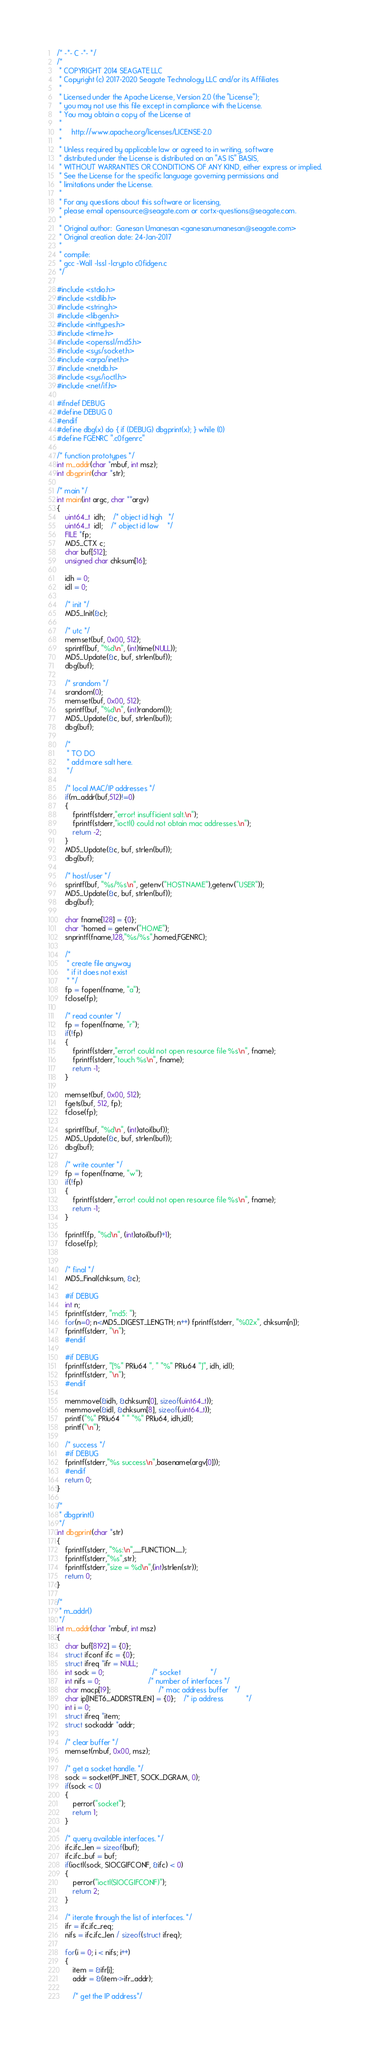Convert code to text. <code><loc_0><loc_0><loc_500><loc_500><_C_>/* -*- C -*- */
/*
 * COPYRIGHT 2014 SEAGATE LLC
 * Copyright (c) 2017-2020 Seagate Technology LLC and/or its Affiliates
 *
 * Licensed under the Apache License, Version 2.0 (the "License");
 * you may not use this file except in compliance with the License.
 * You may obtain a copy of the License at
 *
 *     http://www.apache.org/licenses/LICENSE-2.0
 *
 * Unless required by applicable law or agreed to in writing, software
 * distributed under the License is distributed on an "AS IS" BASIS,
 * WITHOUT WARRANTIES OR CONDITIONS OF ANY KIND, either express or implied.
 * See the License for the specific language governing permissions and
 * limitations under the License.
 *
 * For any questions about this software or licensing,
 * please email opensource@seagate.com or cortx-questions@seagate.com.
 *
 * Original author:  Ganesan Umanesan <ganesan.umanesan@seagate.com>
 * Original creation date: 24-Jan-2017
 *
 * compile:
 * gcc -Wall -lssl -lcrypto c0fidgen.c
 */

#include <stdio.h>
#include <stdlib.h>
#include <string.h>
#include <libgen.h>
#include <inttypes.h>
#include <time.h>
#include <openssl/md5.h>
#include <sys/socket.h>
#include <arpa/inet.h>
#include <netdb.h>
#include <sys/ioctl.h>
#include <net/if.h>

#ifndef DEBUG
#define DEBUG 0
#endif
#define dbg(x) do { if (DEBUG) dbgprint(x); } while (0)
#define FGENRC ".c0fgenrc"

/* function prototypes */
int m_addr(char *mbuf, int msz);
int dbgprint(char *str);

/* main */
int main(int argc, char **argv)
{
	uint64_t  idh;	/* object id high 	*/
	uint64_t  idl;	/* object id low	*/
    FILE *fp;
    MD5_CTX c;
    char buf[512];
    unsigned char chksum[16];

	idh = 0;
	idl = 0;

	/* init */
    MD5_Init(&c);

    /* utc */
    memset(buf, 0x00, 512);
    sprintf(buf, "%d\n", (int)time(NULL));
    MD5_Update(&c, buf, strlen(buf));
    dbg(buf);

    /* srandom */
	srandom(0);
    memset(buf, 0x00, 512);
    sprintf(buf, "%d\n", (int)random());
    MD5_Update(&c, buf, strlen(buf));
    dbg(buf);

    /*
     * TO DO
     * add more salt here.
     */

    /* local MAC/IP addresses */
	if(m_addr(buf,512)!=0)
	{
		fprintf(stderr,"error! insufficient salt.\n");
		fprintf(stderr,"ioctl() could not obtain mac addresses.\n");
		return -2;
	}
    MD5_Update(&c, buf, strlen(buf));
    dbg(buf);

    /* host/user */
    sprintf(buf, "%s/%s\n", getenv("HOSTNAME"),getenv("USER"));
    MD5_Update(&c, buf, strlen(buf));
    dbg(buf);

    char fname[128] = {0};
    char *homed = getenv("HOME");
	snprintf(fname,128,"%s/%s",homed,FGENRC);

	/*
	 * create file anyway
	 * if it does not exist
	 * */
    fp = fopen(fname, "a");
    fclose(fp);

	/* read counter */
    fp = fopen(fname, "r");
    if(!fp)
    {
        fprintf(stderr,"error! could not open resource file %s\n", fname);
        fprintf(stderr,"touch %s\n", fname);
        return -1;
    }

    memset(buf, 0x00, 512);
    fgets(buf, 512, fp);
    fclose(fp);

    sprintf(buf, "%d\n", (int)atoi(buf));
    MD5_Update(&c, buf, strlen(buf));
    dbg(buf);

    /* write counter */
    fp = fopen(fname, "w");
    if(!fp)
    {
        fprintf(stderr,"error! could not open resource file %s\n", fname);
        return -1;
    }

    fprintf(fp, "%d\n", (int)atoi(buf)+1);
    fclose(fp);


	/* final */
    MD5_Final(chksum, &c);

	#if DEBUG
    int n;
    fprintf(stderr, "md5: ");
    for(n=0; n<MD5_DIGEST_LENGTH; n++) fprintf(stderr, "%02x", chksum[n]);
    fprintf(stderr, "\n");
	#endif

	#if DEBUG
	fprintf(stderr, "[%" PRIu64 ", " "%" PRIu64 "]", idh, idl);
	fprintf(stderr, "\n");
	#endif

	memmove(&idh, &chksum[0], sizeof(uint64_t));
	memmove(&idl, &chksum[8], sizeof(uint64_t));
	printf("%" PRIu64 " " "%" PRIu64, idh,idl);
	printf("\n");

	/* success */
	#if DEBUG
	fprintf(stderr,"%s success\n",basename(argv[0]));
	#endif
	return 0;
}

/*
 * dbgprint()
 */
int dbgprint(char *str)
{
    fprintf(stderr, "%s:\n",__FUNCTION__);
    fprintf(stderr,"%s",str);
    fprintf(stderr,"size = %d\n",(int)strlen(str));
	return 0;
}

/*
 * m_addr()
 */
int m_addr(char *mbuf, int msz)
{
	char buf[8192] = {0};
	struct ifconf ifc = {0};
	struct ifreq *ifr = NULL;
	int sock = 0;						/* socket				*/
	int nifs = 0;						/* number of interfaces	*/
	char macp[19];						/* mac address buffer	*/
	char ip[INET6_ADDRSTRLEN] = {0};	/* ip address			*/
	int i = 0;
	struct ifreq *item;
	struct sockaddr *addr;

	/* clear buffer */
	memset(mbuf, 0x00, msz);

	/* get a socket handle. */
	sock = socket(PF_INET, SOCK_DGRAM, 0);
	if(sock < 0)
	{
		perror("socket");
		return 1;
	}

	/* query available interfaces. */
	ifc.ifc_len = sizeof(buf);
	ifc.ifc_buf = buf;
	if(ioctl(sock, SIOCGIFCONF, &ifc) < 0)
	{
		perror("ioctl(SIOCGIFCONF)");
		return 2;
	}

	/* iterate through the list of interfaces. */
	ifr = ifc.ifc_req;
	nifs = ifc.ifc_len / sizeof(struct ifreq);

	for(i = 0; i < nifs; i++)
	{
		item = &ifr[i];
		addr = &(item->ifr_addr);

		/* get the IP address*/</code> 